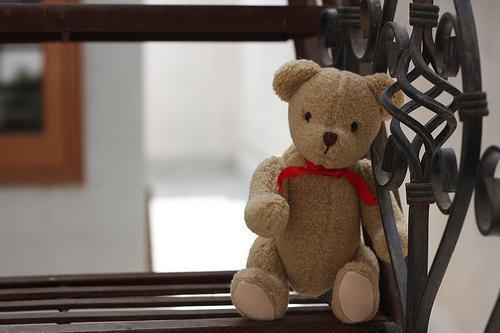How many toys?
Give a very brief answer. 1. 